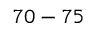<formula> <loc_0><loc_0><loc_500><loc_500>7 0 - 7 5 \</formula> 